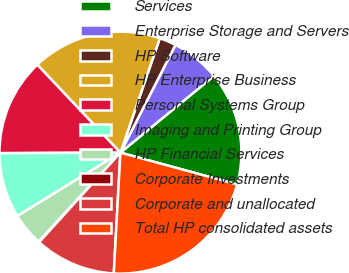Convert chart to OTSL. <chart><loc_0><loc_0><loc_500><loc_500><pie_chart><fcel>Services<fcel>Enterprise Storage and Servers<fcel>HP Software<fcel>HP Enterprise Business<fcel>Personal Systems Group<fcel>Imaging and Printing Group<fcel>HP Financial Services<fcel>Corporate Investments<fcel>Corporate and unallocated<fcel>Total HP consolidated assets<nl><fcel>15.17%<fcel>6.55%<fcel>2.24%<fcel>17.33%<fcel>13.02%<fcel>8.71%<fcel>4.4%<fcel>0.09%<fcel>10.86%<fcel>21.64%<nl></chart> 